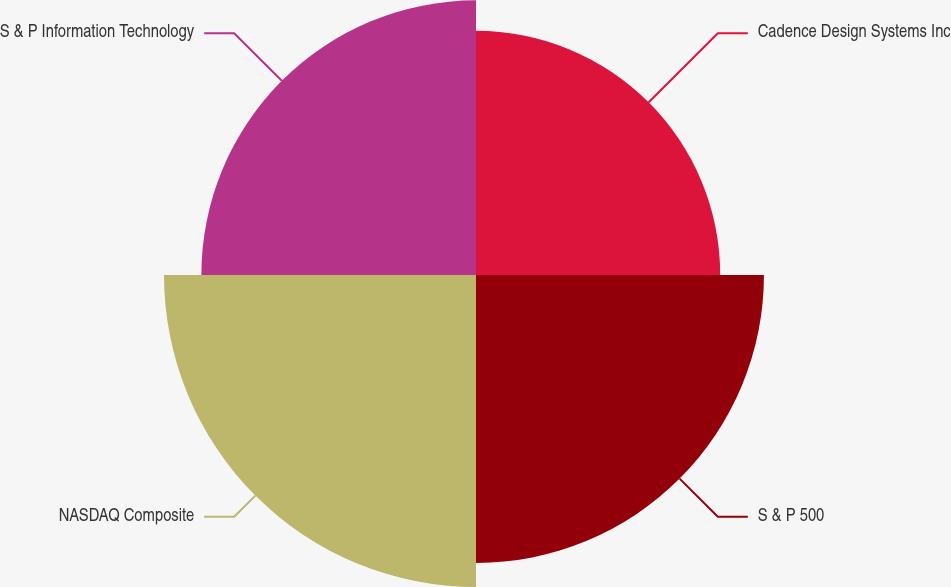<chart> <loc_0><loc_0><loc_500><loc_500><pie_chart><fcel>Cadence Design Systems Inc<fcel>S & P 500<fcel>NASDAQ Composite<fcel>S & P Information Technology<nl><fcel>21.83%<fcel>25.74%<fcel>27.89%<fcel>24.55%<nl></chart> 